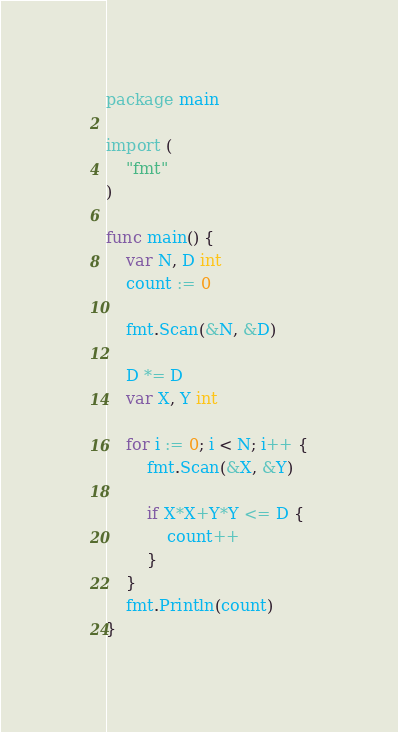<code> <loc_0><loc_0><loc_500><loc_500><_Go_>package main

import (
	"fmt"
)

func main() {
	var N, D int
	count := 0

	fmt.Scan(&N, &D)

	D *= D
	var X, Y int

	for i := 0; i < N; i++ {
		fmt.Scan(&X, &Y)

		if X*X+Y*Y <= D {
			count++
		}
	}
	fmt.Println(count)
}
</code> 